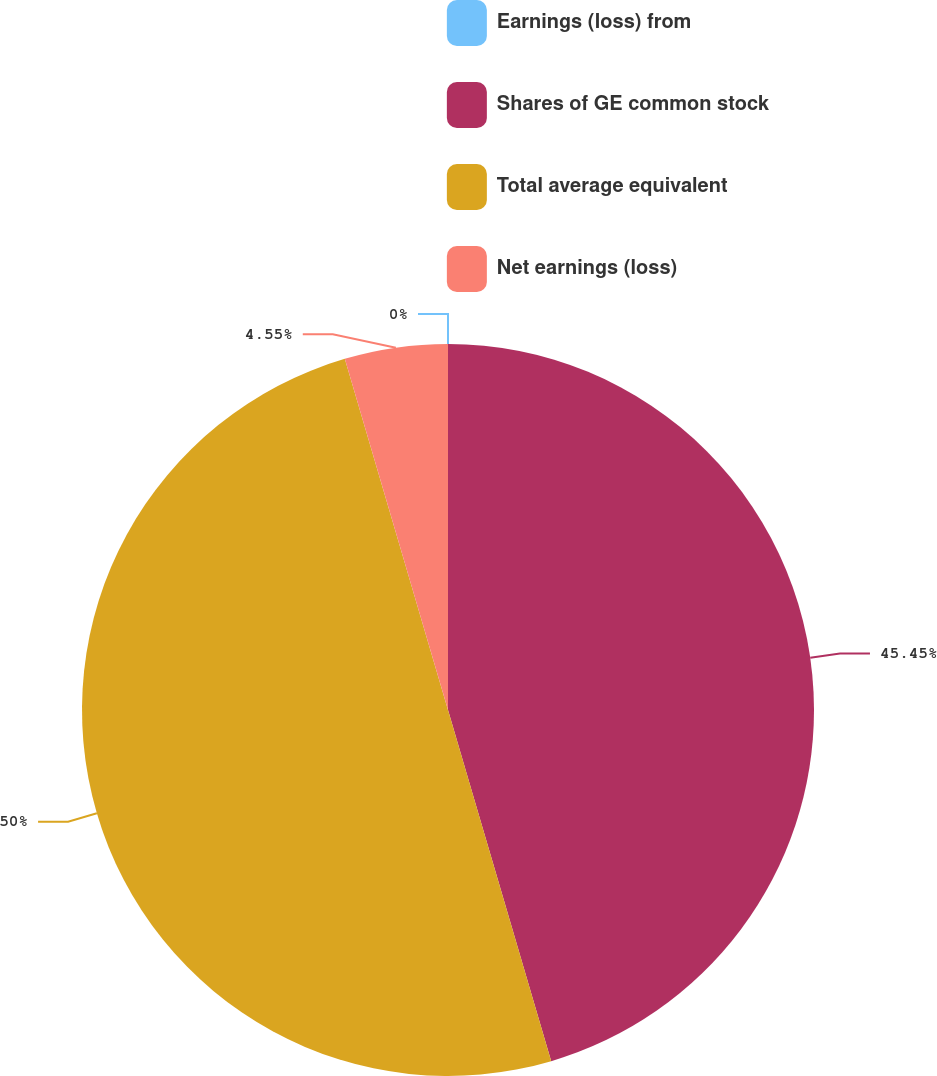Convert chart to OTSL. <chart><loc_0><loc_0><loc_500><loc_500><pie_chart><fcel>Earnings (loss) from<fcel>Shares of GE common stock<fcel>Total average equivalent<fcel>Net earnings (loss)<nl><fcel>0.0%<fcel>45.45%<fcel>50.0%<fcel>4.55%<nl></chart> 